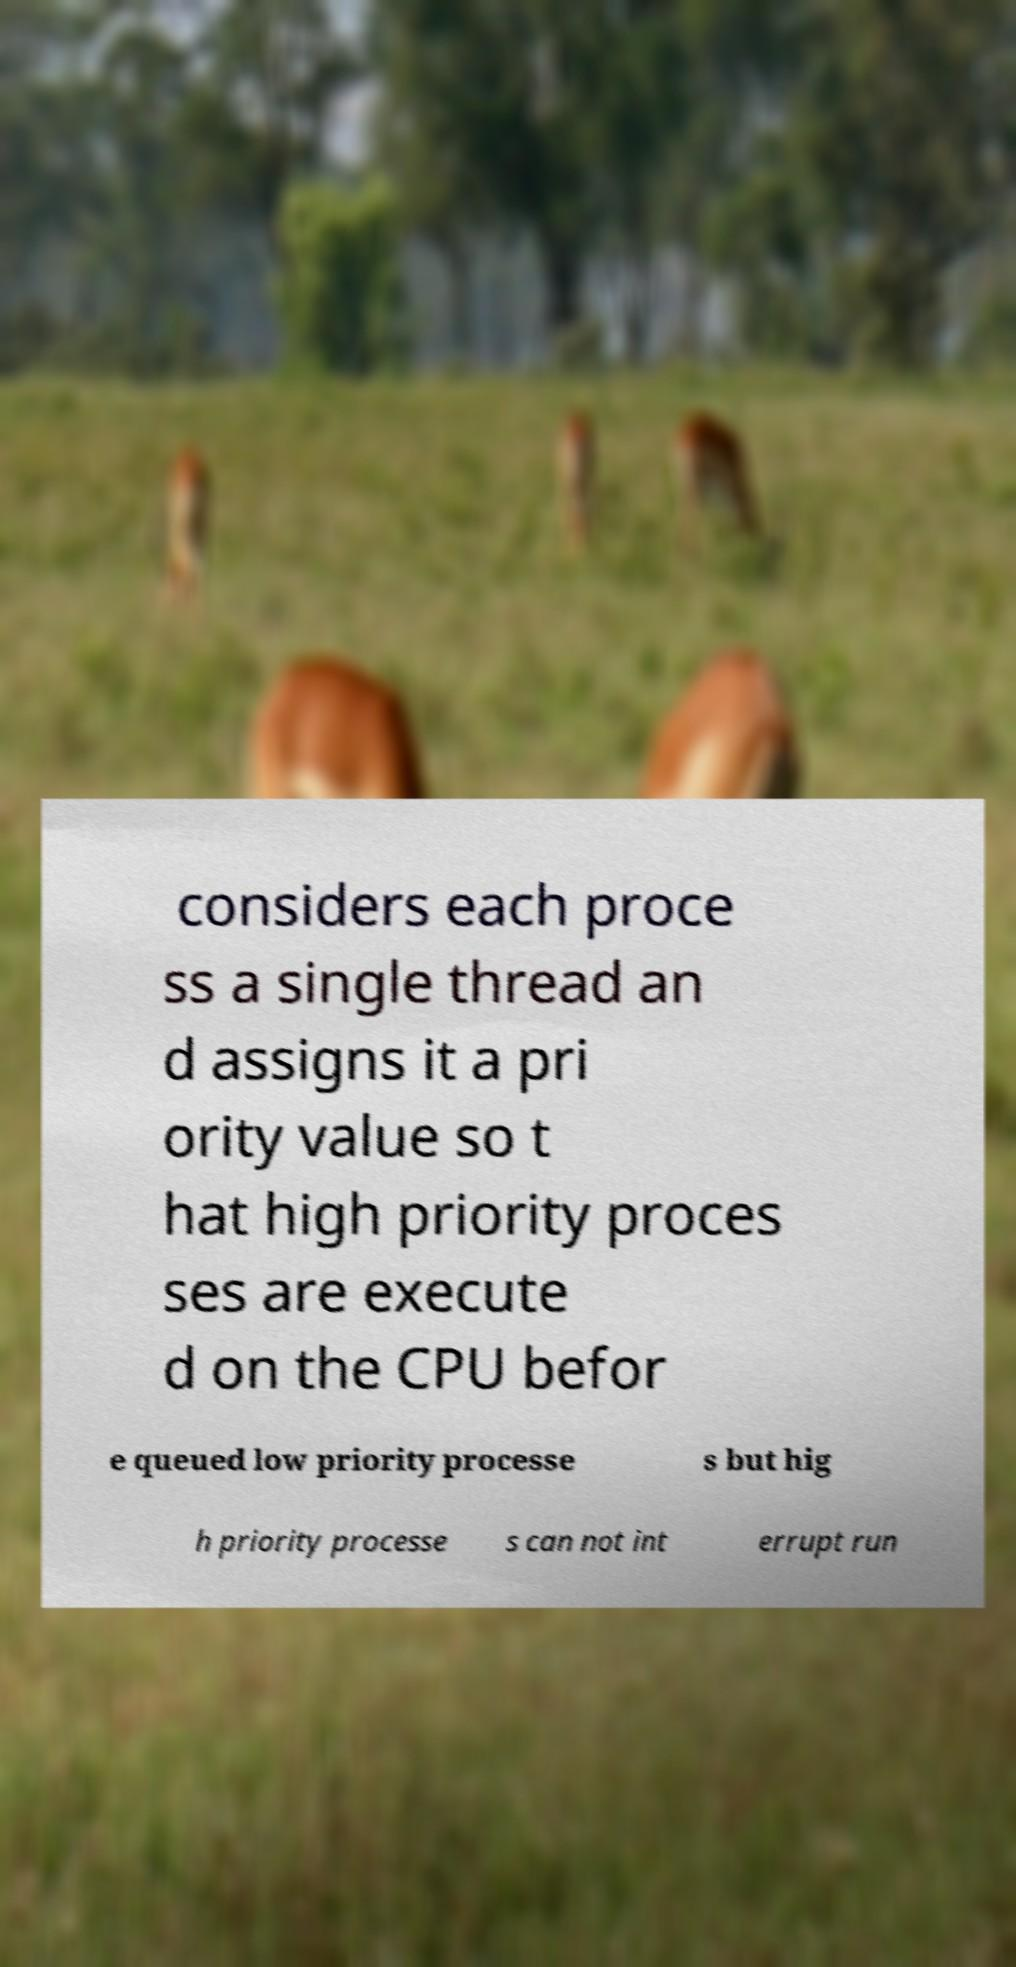Please read and relay the text visible in this image. What does it say? considers each proce ss a single thread an d assigns it a pri ority value so t hat high priority proces ses are execute d on the CPU befor e queued low priority processe s but hig h priority processe s can not int errupt run 